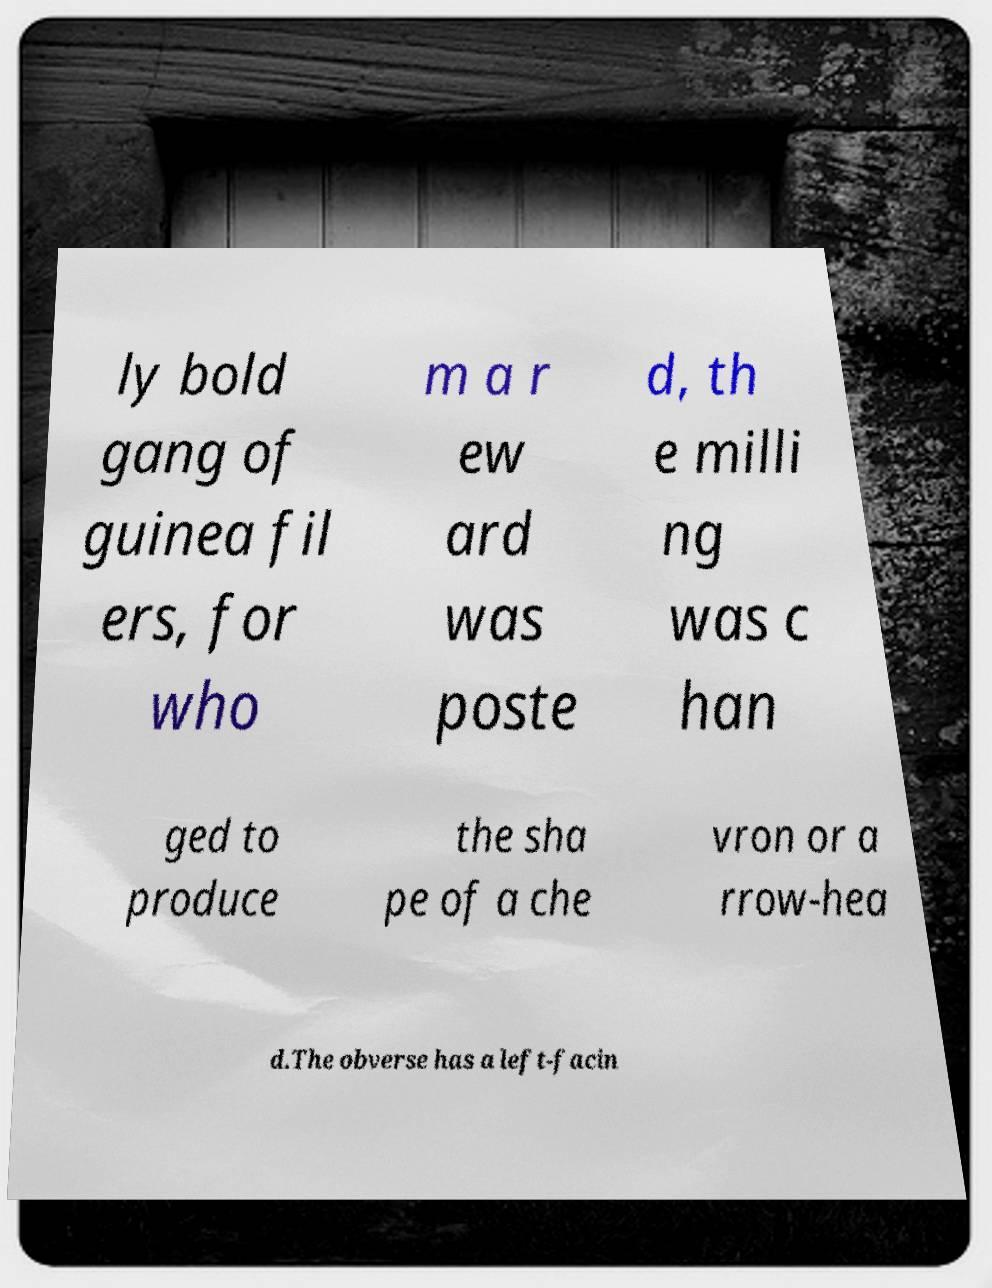For documentation purposes, I need the text within this image transcribed. Could you provide that? ly bold gang of guinea fil ers, for who m a r ew ard was poste d, th e milli ng was c han ged to produce the sha pe of a che vron or a rrow-hea d.The obverse has a left-facin 